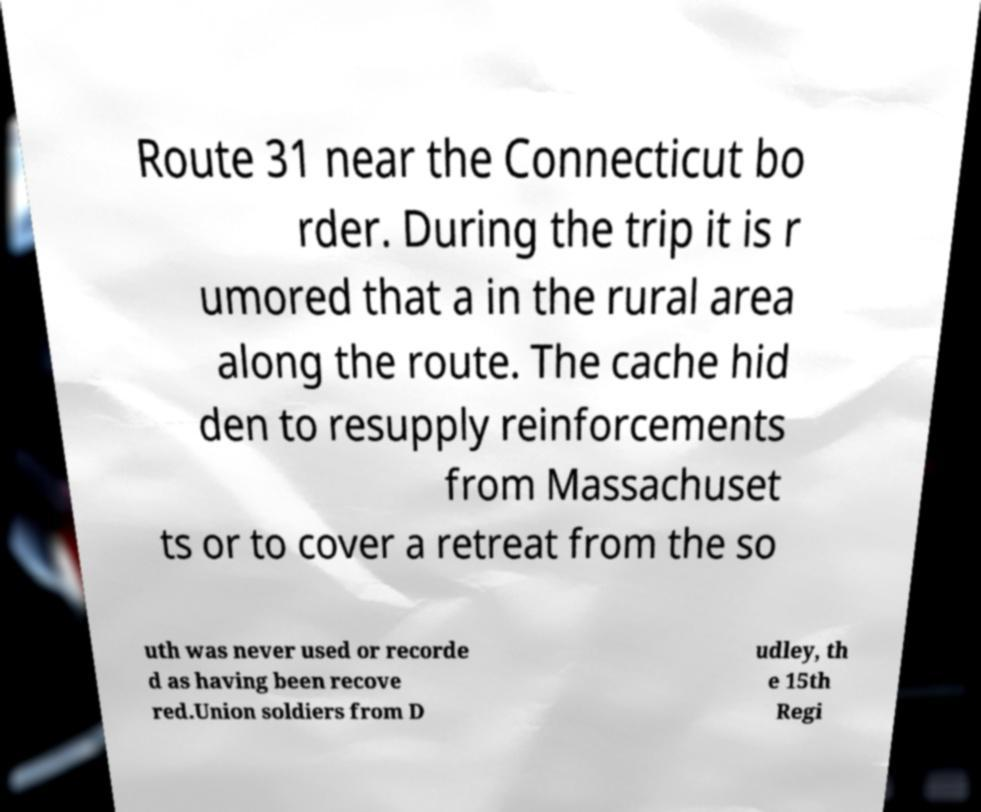Can you accurately transcribe the text from the provided image for me? Route 31 near the Connecticut bo rder. During the trip it is r umored that a in the rural area along the route. The cache hid den to resupply reinforcements from Massachuset ts or to cover a retreat from the so uth was never used or recorde d as having been recove red.Union soldiers from D udley, th e 15th Regi 